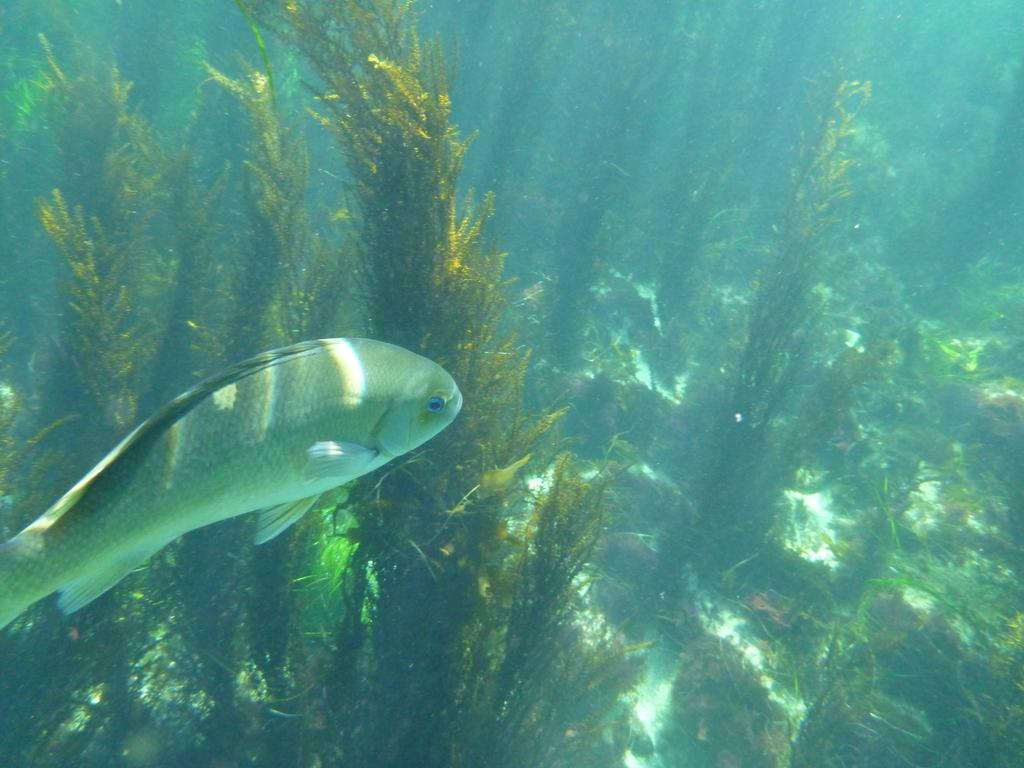What type of living organisms can be seen in the image? Plants and fish are visible in the image. Where are the fish located in the image? The fish are visible underwater in the image. What type of wrench is being used to open the jar in the image? There is no wrench or jar present in the image; it features plants and fish. 